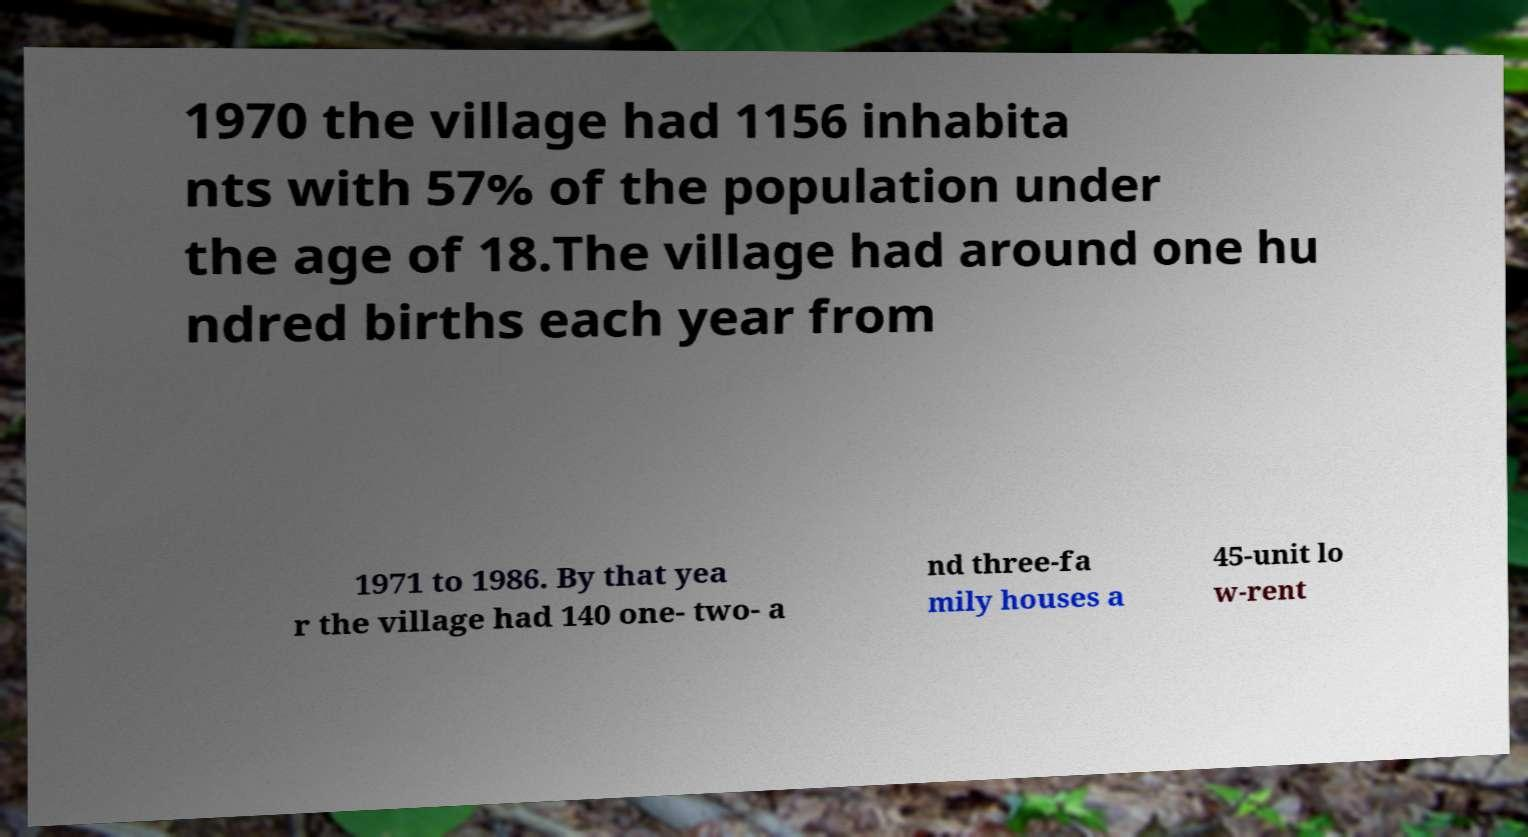Could you assist in decoding the text presented in this image and type it out clearly? 1970 the village had 1156 inhabita nts with 57% of the population under the age of 18.The village had around one hu ndred births each year from 1971 to 1986. By that yea r the village had 140 one- two- a nd three-fa mily houses a 45-unit lo w-rent 